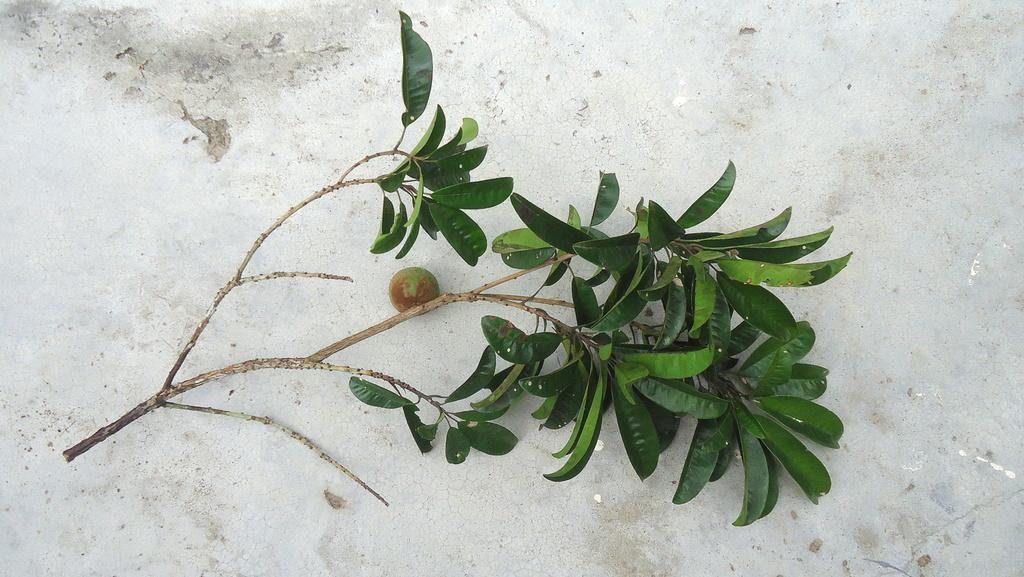What is attached to the stem in the image? The stem has a fruit and leaves in the image. Where is the stem located in the image? The stem is on the floor in the image. How many bikes are parked near the stem in the image? There are no bikes present in the image. What type of surprise can be seen near the stem in the image? There is no surprise present in the image. 